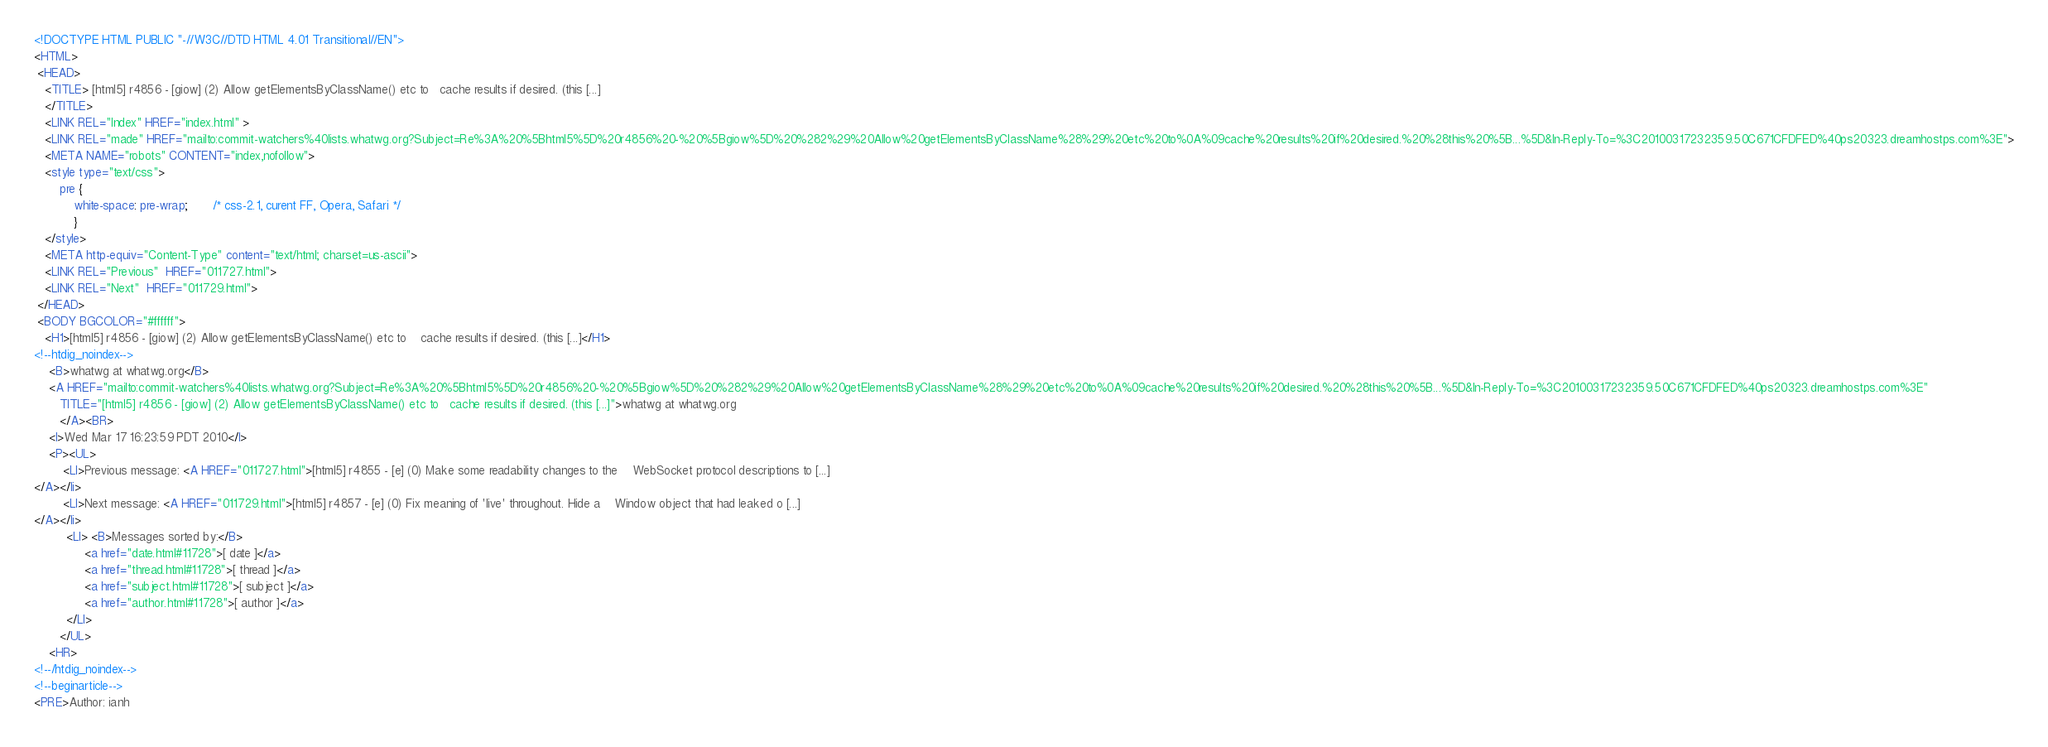Convert code to text. <code><loc_0><loc_0><loc_500><loc_500><_HTML_><!DOCTYPE HTML PUBLIC "-//W3C//DTD HTML 4.01 Transitional//EN">
<HTML>
 <HEAD>
   <TITLE> [html5] r4856 - [giow] (2) Allow getElementsByClassName() etc to	cache results if desired. (this [...]
   </TITLE>
   <LINK REL="Index" HREF="index.html" >
   <LINK REL="made" HREF="mailto:commit-watchers%40lists.whatwg.org?Subject=Re%3A%20%5Bhtml5%5D%20r4856%20-%20%5Bgiow%5D%20%282%29%20Allow%20getElementsByClassName%28%29%20etc%20to%0A%09cache%20results%20if%20desired.%20%28this%20%5B...%5D&In-Reply-To=%3C20100317232359.50C671CFDFED%40ps20323.dreamhostps.com%3E">
   <META NAME="robots" CONTENT="index,nofollow">
   <style type="text/css">
       pre {
           white-space: pre-wrap;       /* css-2.1, curent FF, Opera, Safari */
           }
   </style>
   <META http-equiv="Content-Type" content="text/html; charset=us-ascii">
   <LINK REL="Previous"  HREF="011727.html">
   <LINK REL="Next"  HREF="011729.html">
 </HEAD>
 <BODY BGCOLOR="#ffffff">
   <H1>[html5] r4856 - [giow] (2) Allow getElementsByClassName() etc to	cache results if desired. (this [...]</H1>
<!--htdig_noindex-->
    <B>whatwg at whatwg.org</B> 
    <A HREF="mailto:commit-watchers%40lists.whatwg.org?Subject=Re%3A%20%5Bhtml5%5D%20r4856%20-%20%5Bgiow%5D%20%282%29%20Allow%20getElementsByClassName%28%29%20etc%20to%0A%09cache%20results%20if%20desired.%20%28this%20%5B...%5D&In-Reply-To=%3C20100317232359.50C671CFDFED%40ps20323.dreamhostps.com%3E"
       TITLE="[html5] r4856 - [giow] (2) Allow getElementsByClassName() etc to	cache results if desired. (this [...]">whatwg at whatwg.org
       </A><BR>
    <I>Wed Mar 17 16:23:59 PDT 2010</I>
    <P><UL>
        <LI>Previous message: <A HREF="011727.html">[html5] r4855 - [e] (0) Make some readability changes to the	WebSocket protocol descriptions to [...]
</A></li>
        <LI>Next message: <A HREF="011729.html">[html5] r4857 - [e] (0) Fix meaning of 'live' throughout. Hide a	Window object that had leaked o [...]
</A></li>
         <LI> <B>Messages sorted by:</B> 
              <a href="date.html#11728">[ date ]</a>
              <a href="thread.html#11728">[ thread ]</a>
              <a href="subject.html#11728">[ subject ]</a>
              <a href="author.html#11728">[ author ]</a>
         </LI>
       </UL>
    <HR>  
<!--/htdig_noindex-->
<!--beginarticle-->
<PRE>Author: ianh</code> 